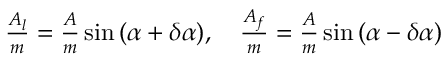Convert formula to latex. <formula><loc_0><loc_0><loc_500><loc_500>\begin{array} { r } { \frac { A _ { l } } { m } = \frac { A } { m } \sin { ( \alpha + \delta \alpha ) } , \quad \frac { A _ { f } } { m } = \frac { A } { m } \sin { ( \alpha - \delta \alpha ) } } \end{array}</formula> 